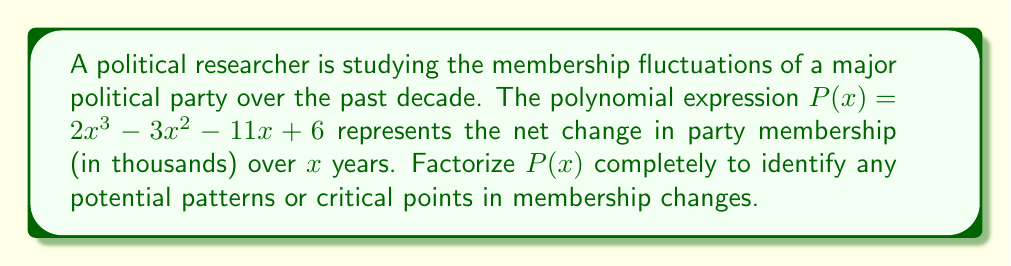Show me your answer to this math problem. To factorize the polynomial $P(x) = 2x^3 - 3x^2 - 11x + 6$, we'll follow these steps:

1) First, let's check if there are any common factors:
   There are no common factors among all terms.

2) Next, we'll use the rational root theorem to find potential roots. The possible rational roots are the factors of the constant term (6) divided by the factors of the leading coefficient (2):
   Potential roots: $\pm 1, \pm 2, \pm 3, \pm 6, \pm \frac{1}{2}, \pm \frac{3}{2}$

3) Testing these values, we find that $x = 1$ is a root of the polynomial.

4) We can now use polynomial long division to divide $P(x)$ by $(x - 1)$:

   $$
   \begin{array}{r}
   2x^2 + x - 6 \\
   x - 1 \enclose{longdiv}{2x^3 - 3x^2 - 11x + 6} \\
   \underline{2x^3 - 2x^2} \\
   -x^2 - 11x \\
   \underline{-x^2 + x} \\
   -12x + 6 \\
   \underline{-12x + 12} \\
   -6
   \end{array}
   $$

5) So, $P(x) = (x - 1)(2x^2 + x - 6)$

6) Now we need to factorize $2x^2 + x - 6$. We can do this by finding two numbers that multiply to give $-12$ (which is $2 \times -6$) and add up to $1$. These numbers are $4$ and $-3$.

7) Therefore, $2x^2 + x - 6 = 2x^2 + 4x - 3x - 6 = 2x(x + 2) - 3(x + 2) = (2x - 3)(x + 2)$

8) Combining all factors, we get the final factorization:
   $P(x) = (x - 1)(2x - 3)(x + 2)$

This factorization reveals three critical points in the membership changes: when $x = 1$, $x = \frac{3}{2}$, and $x = -2$. These points represent years when the net change in membership was zero, potentially indicating shifts in party dynamics or external political events.
Answer: $P(x) = (x - 1)(2x - 3)(x + 2)$ 